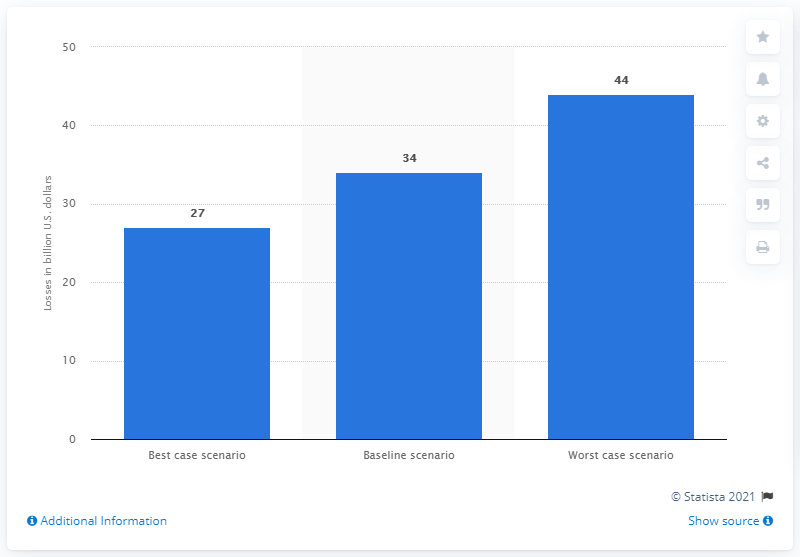List a handful of essential elements in this visual. In a best case scenario, the immediate actions taken for the recovery of the tourism sector in the region could result in a significant increase in tourism GDP, potentially reaching X amount. In a worst-case scenario, the travel and tourism industry could suffer losses of up to $44 billion in U.S. dollars. 